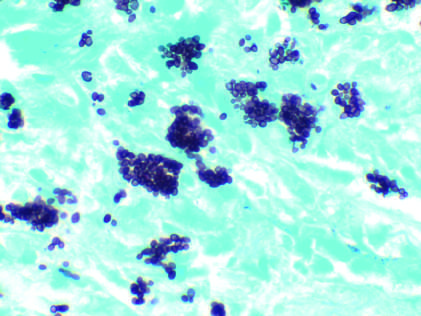does the bronchial biopsy specimen from an asthmatic patient fill phagocytes in a lymph node of a patient with disseminated histoplasmosis silver stain?
Answer the question using a single word or phrase. No 